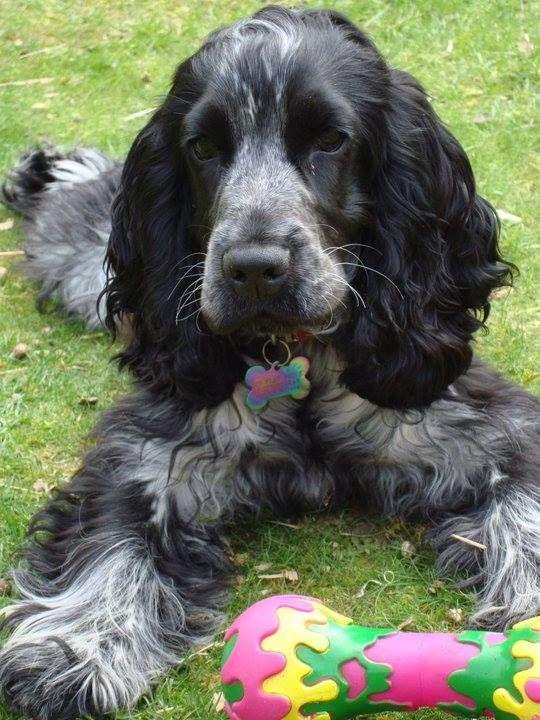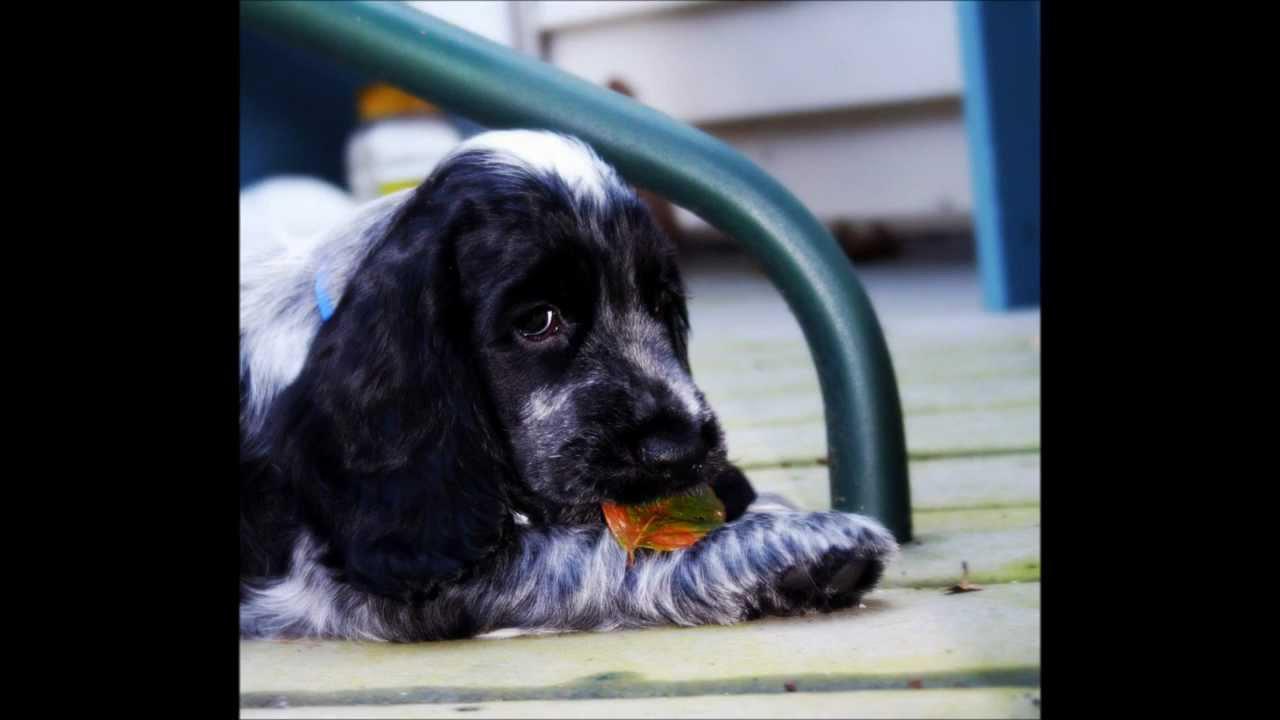The first image is the image on the left, the second image is the image on the right. For the images displayed, is the sentence "An image shows one dog interacting with a stick-shaped item that is at least partly brown." factually correct? Answer yes or no. No. The first image is the image on the left, the second image is the image on the right. Analyze the images presented: Is the assertion "The dog in the image on the left is lying on the grass." valid? Answer yes or no. Yes. 